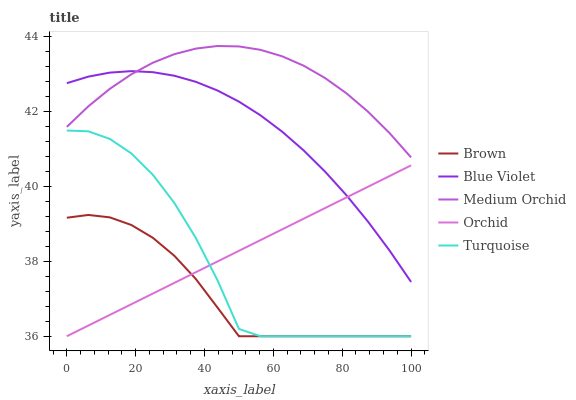Does Brown have the minimum area under the curve?
Answer yes or no. Yes. Does Medium Orchid have the maximum area under the curve?
Answer yes or no. Yes. Does Turquoise have the minimum area under the curve?
Answer yes or no. No. Does Turquoise have the maximum area under the curve?
Answer yes or no. No. Is Orchid the smoothest?
Answer yes or no. Yes. Is Turquoise the roughest?
Answer yes or no. Yes. Is Medium Orchid the smoothest?
Answer yes or no. No. Is Medium Orchid the roughest?
Answer yes or no. No. Does Brown have the lowest value?
Answer yes or no. Yes. Does Medium Orchid have the lowest value?
Answer yes or no. No. Does Medium Orchid have the highest value?
Answer yes or no. Yes. Does Turquoise have the highest value?
Answer yes or no. No. Is Brown less than Medium Orchid?
Answer yes or no. Yes. Is Blue Violet greater than Turquoise?
Answer yes or no. Yes. Does Blue Violet intersect Medium Orchid?
Answer yes or no. Yes. Is Blue Violet less than Medium Orchid?
Answer yes or no. No. Is Blue Violet greater than Medium Orchid?
Answer yes or no. No. Does Brown intersect Medium Orchid?
Answer yes or no. No. 